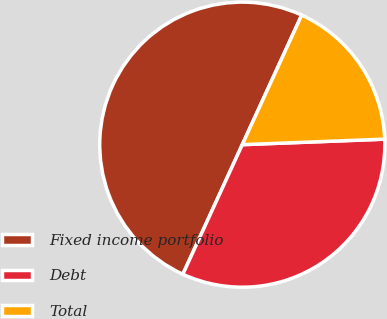Convert chart to OTSL. <chart><loc_0><loc_0><loc_500><loc_500><pie_chart><fcel>Fixed income portfolio<fcel>Debt<fcel>Total<nl><fcel>50.0%<fcel>32.46%<fcel>17.54%<nl></chart> 